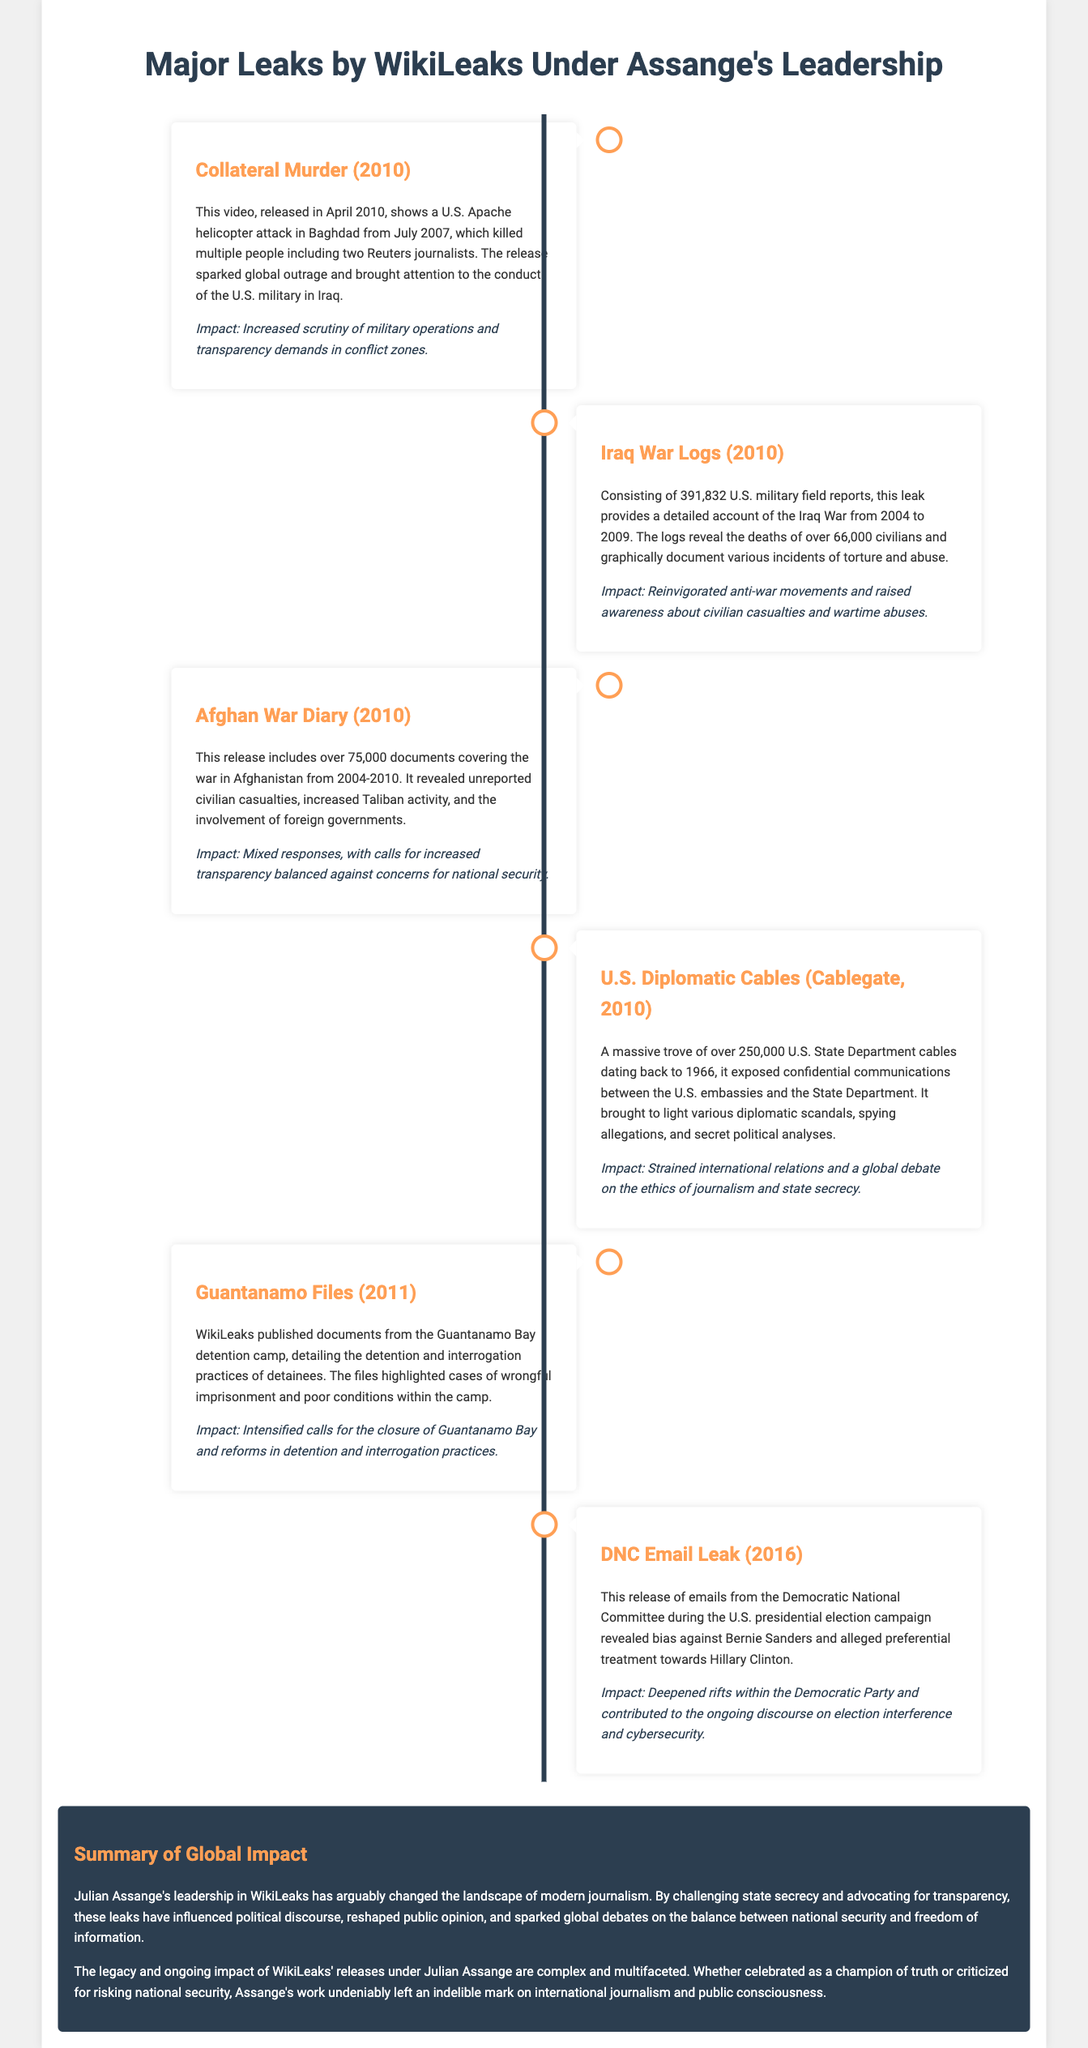What was released in April 2010? The document highlights that the Collateral Murder video was released in April 2010.
Answer: Collateral Murder video How many U.S. military field reports were included in the Iraq War Logs? The document states that the Iraq War Logs consisted of 391,832 U.S. military field reports.
Answer: 391,832 What event does the DNC Email Leak pertain to? The DNC Email Leak is related to the U.S. presidential election campaign.
Answer: U.S. presidential election campaign What impact did the U.S. Diplomatic Cables leak have? The impact mentioned was strained international relations and a global debate.
Answer: Strained international relations What year did WikiLeaks publish the Guantanamo Files? The year stated for the publication of the Guantanamo Files is 2011.
Answer: 2011 Which leak involved over 75,000 documents covering a specific war? The Afghan War Diary involved over 75,000 documents covering the war in Afghanistan.
Answer: Afghan War Diary What was a notable consequence of the Iraq War Logs' release? The document mentions that it reinvigorated anti-war movements.
Answer: Reinvigorated anti-war movements How many U.S. State Department cables were included in Cablegate? The number of U.S. State Department cables included in Cablegate was over 250,000.
Answer: Over 250,000 